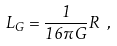Convert formula to latex. <formula><loc_0><loc_0><loc_500><loc_500>L _ { G } = \frac { 1 } { 1 6 \pi G } R \ ,</formula> 